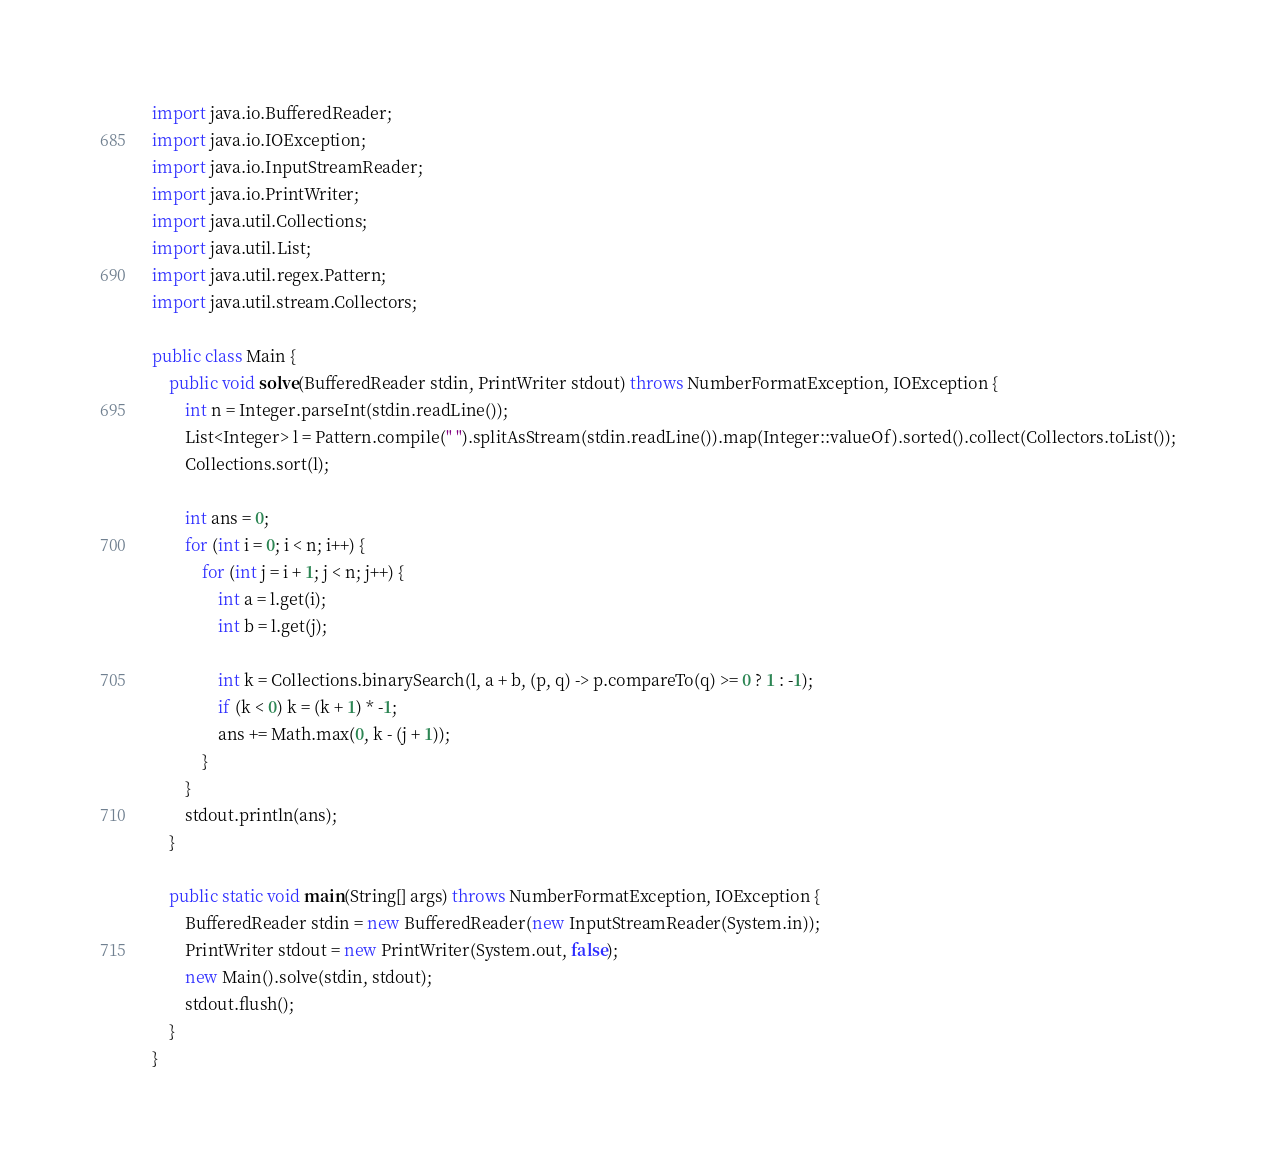Convert code to text. <code><loc_0><loc_0><loc_500><loc_500><_Java_>import java.io.BufferedReader;
import java.io.IOException;
import java.io.InputStreamReader;
import java.io.PrintWriter;
import java.util.Collections;
import java.util.List;
import java.util.regex.Pattern;
import java.util.stream.Collectors;

public class Main {
    public void solve(BufferedReader stdin, PrintWriter stdout) throws NumberFormatException, IOException {
        int n = Integer.parseInt(stdin.readLine());
        List<Integer> l = Pattern.compile(" ").splitAsStream(stdin.readLine()).map(Integer::valueOf).sorted().collect(Collectors.toList());
        Collections.sort(l);

        int ans = 0;
        for (int i = 0; i < n; i++) {
            for (int j = i + 1; j < n; j++) {
                int a = l.get(i);
                int b = l.get(j);

                int k = Collections.binarySearch(l, a + b, (p, q) -> p.compareTo(q) >= 0 ? 1 : -1);
                if (k < 0) k = (k + 1) * -1;
                ans += Math.max(0, k - (j + 1));
            }
        }
        stdout.println(ans);
    }

    public static void main(String[] args) throws NumberFormatException, IOException {
        BufferedReader stdin = new BufferedReader(new InputStreamReader(System.in));
        PrintWriter stdout = new PrintWriter(System.out, false);
        new Main().solve(stdin, stdout);
        stdout.flush();
    }
}
</code> 